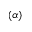<formula> <loc_0><loc_0><loc_500><loc_500>\left ( \alpha \right )</formula> 